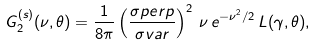<formula> <loc_0><loc_0><loc_500><loc_500>G _ { 2 } ^ { ( s ) } ( \nu , \theta ) = \frac { 1 } { 8 \pi } \left ( \frac { \sigma p e r p } { \sigma v a r } \right ) ^ { 2 } \, \nu \, e ^ { - \nu ^ { 2 } / 2 } \, L ( \gamma , \theta ) ,</formula> 